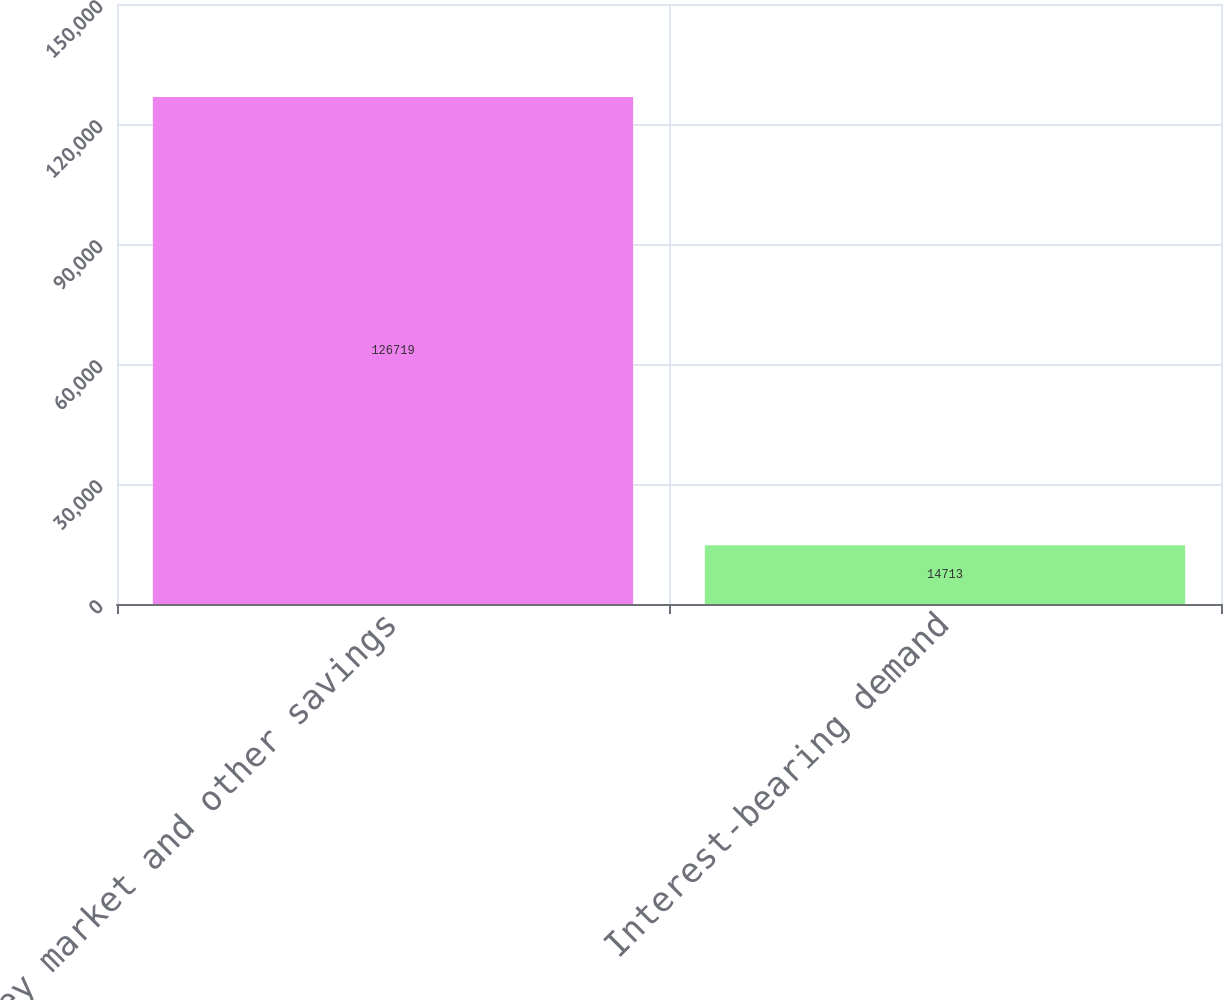Convert chart to OTSL. <chart><loc_0><loc_0><loc_500><loc_500><bar_chart><fcel>Money market and other savings<fcel>Interest-bearing demand<nl><fcel>126719<fcel>14713<nl></chart> 